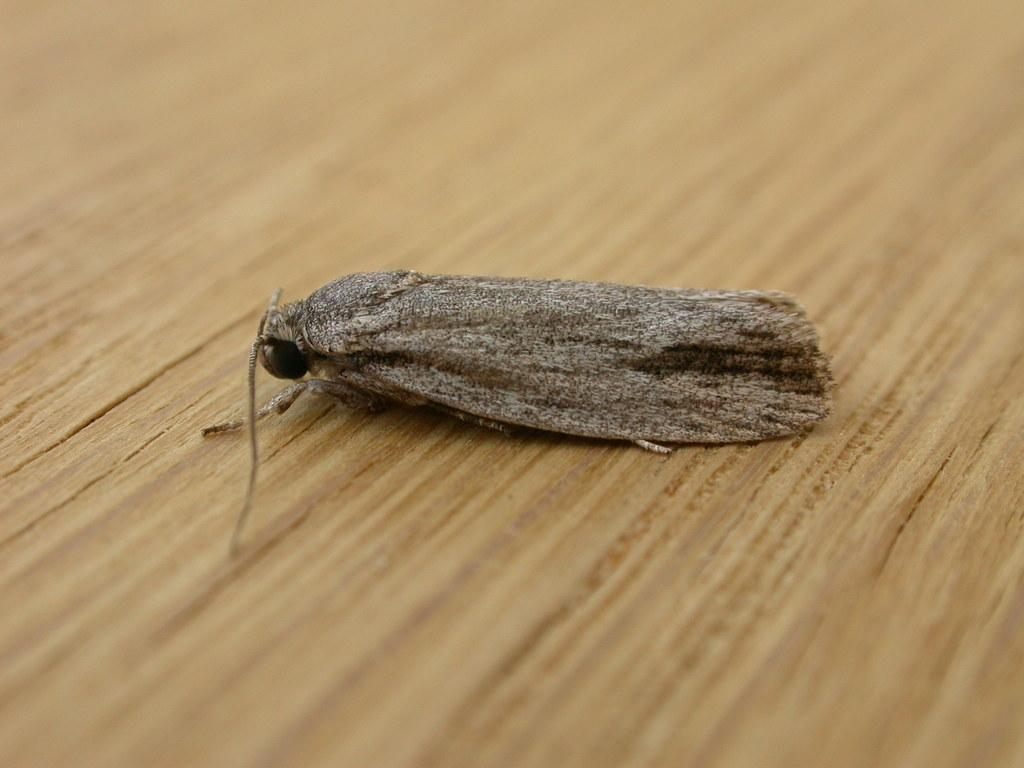What is present on the wooden surface in the image? There is a fly on the wooden surface in the image. Can you describe the surface on which the fly is located? The fly is on a wooden surface. What is the visual effect at the edges of the image? The edges of the image are blurred. How many elbows can be seen in the image? There are no elbows present in the image. What type of pet is visible in the image? There is no pet visible in the image; it only features a fly on a wooden surface. 